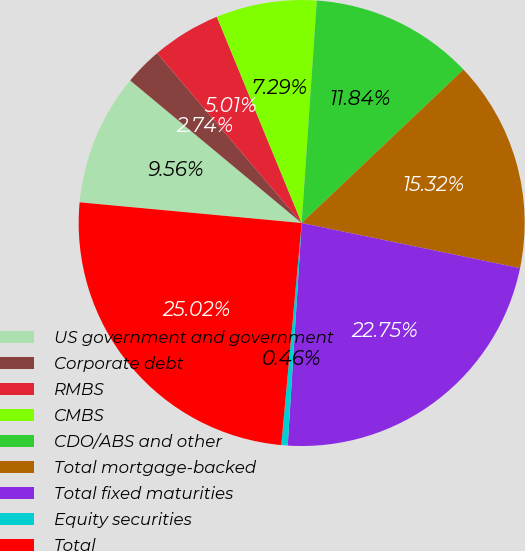Convert chart. <chart><loc_0><loc_0><loc_500><loc_500><pie_chart><fcel>US government and government<fcel>Corporate debt<fcel>RMBS<fcel>CMBS<fcel>CDO/ABS and other<fcel>Total mortgage-backed<fcel>Total fixed maturities<fcel>Equity securities<fcel>Total<nl><fcel>9.56%<fcel>2.74%<fcel>5.01%<fcel>7.29%<fcel>11.84%<fcel>15.32%<fcel>22.75%<fcel>0.46%<fcel>25.02%<nl></chart> 